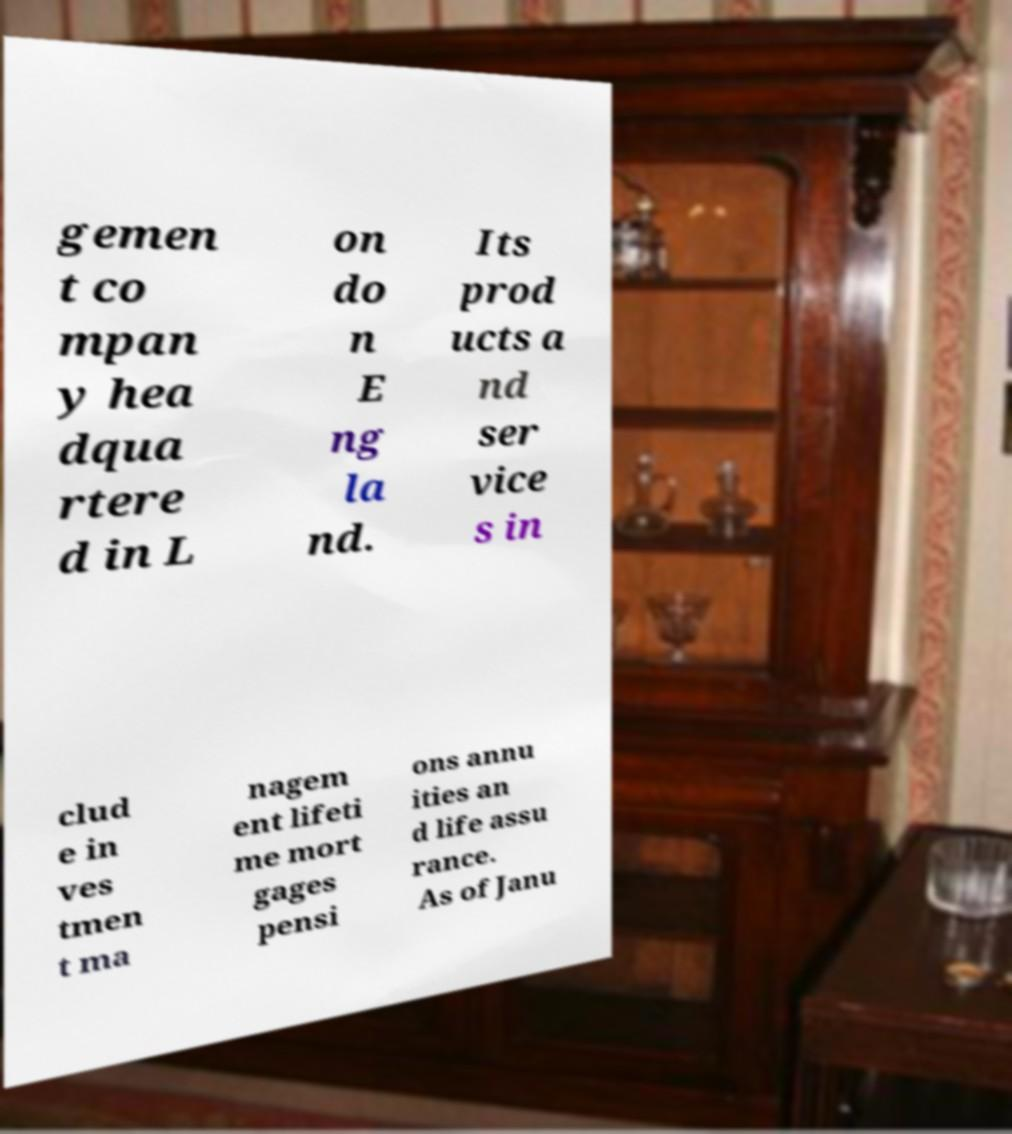For documentation purposes, I need the text within this image transcribed. Could you provide that? gemen t co mpan y hea dqua rtere d in L on do n E ng la nd. Its prod ucts a nd ser vice s in clud e in ves tmen t ma nagem ent lifeti me mort gages pensi ons annu ities an d life assu rance. As of Janu 